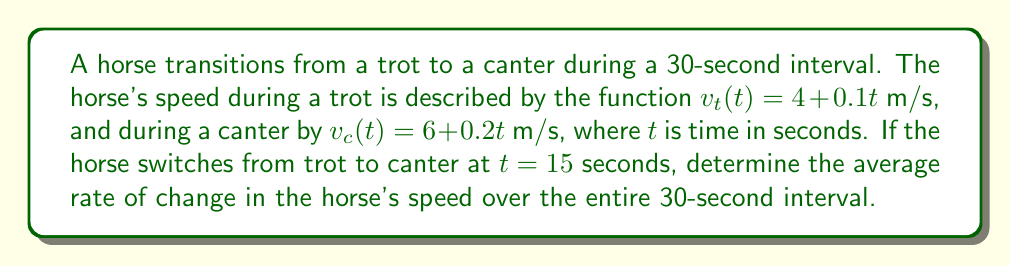Show me your answer to this math problem. To solve this problem, we need to follow these steps:

1) First, let's calculate the speed at the beginning and end of the interval:

   Initial speed (at $t = 0$): $v_t(0) = 4 + 0.1(0) = 4$ m/s
   Final speed (at $t = 30$): $v_c(30) = 6 + 0.2(30) = 12$ m/s

2) Now, we need to find the total change in speed:

   $\Delta v = v_{final} - v_{initial} = 12 - 4 = 8$ m/s

3) The average rate of change is given by the formula:

   $$\text{Average rate of change} = \frac{\Delta v}{\Delta t}$$

   Where $\Delta v$ is the change in speed and $\Delta t$ is the change in time.

4) We know $\Delta v = 8$ m/s and $\Delta t = 30$ seconds, so:

   $$\text{Average rate of change} = \frac{8 \text{ m/s}}{30 \text{ s}} = \frac{4}{15} \text{ m/s}^2 = 0.2667 \text{ m/s}^2$$

Therefore, the average rate of change in the horse's speed over the 30-second interval is $\frac{4}{15}$ m/s² or approximately 0.2667 m/s².
Answer: $\frac{4}{15}$ m/s² or 0.2667 m/s² 